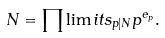Convert formula to latex. <formula><loc_0><loc_0><loc_500><loc_500>N = \prod \lim i t s _ { p | N } p ^ { e _ { p } } .</formula> 